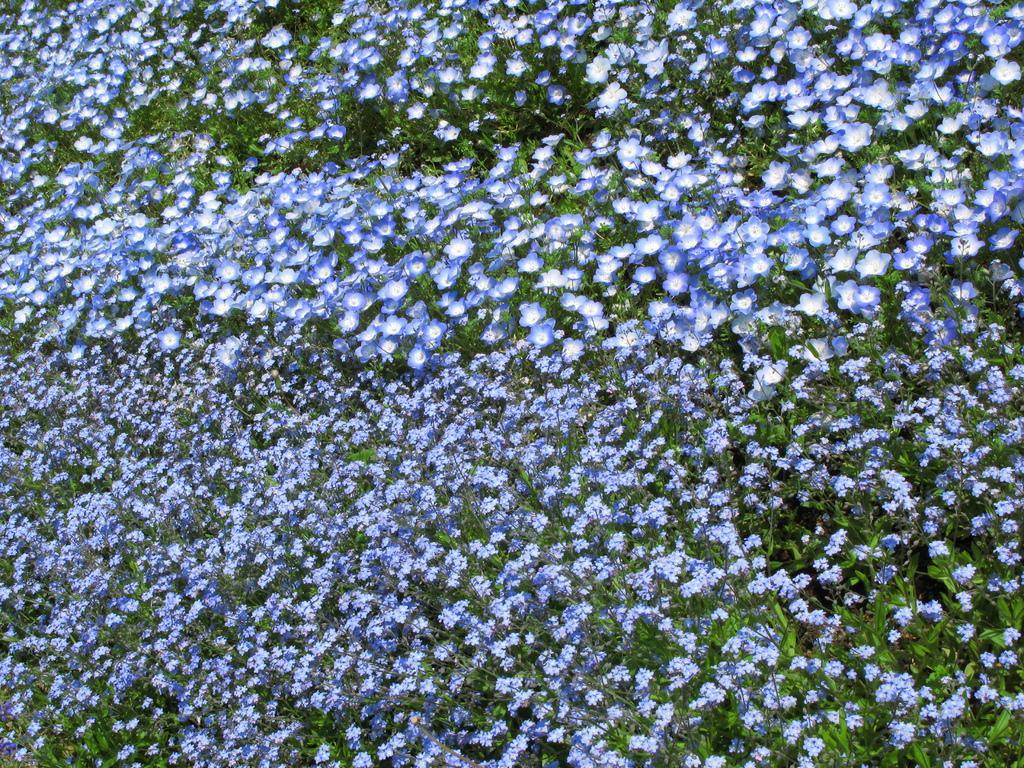Describe this image in one or two sentences. In this image we can see few plants with flowers. 